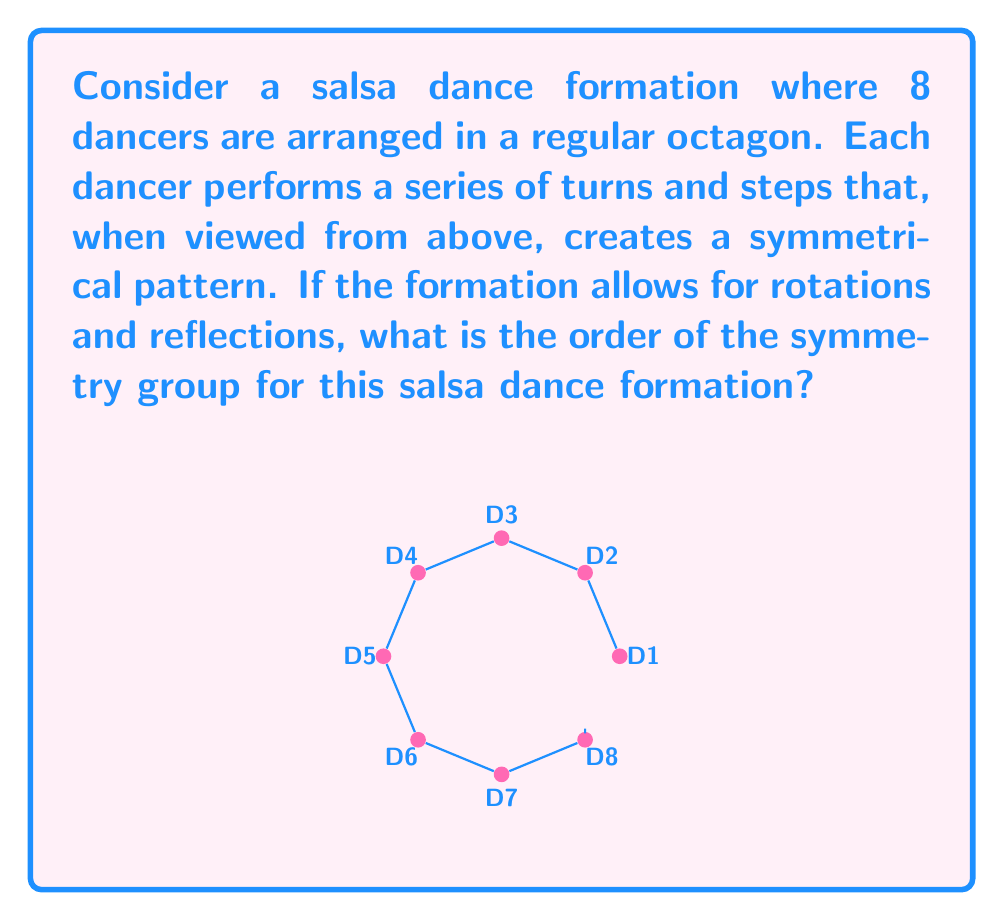Can you solve this math problem? Let's approach this step-by-step:

1) The symmetry group of a regular octagon is known as the dihedral group $D_8$.

2) The elements of $D_8$ consist of:
   - The identity transformation (do nothing)
   - 7 rotations (45°, 90°, 135°, 180°, 225°, 270°, 315°)
   - 8 reflections (4 through vertices and 4 through midpoints of sides)

3) To count the number of elements:
   - 1 identity transformation
   - 7 rotations
   - 8 reflections

4) The total number of elements in the group is the sum of these:
   $1 + 7 + 8 = 16$

5) In group theory, the number of elements in a group is called its order.

Therefore, the order of the symmetry group for this salsa dance formation is 16.
Answer: 16 